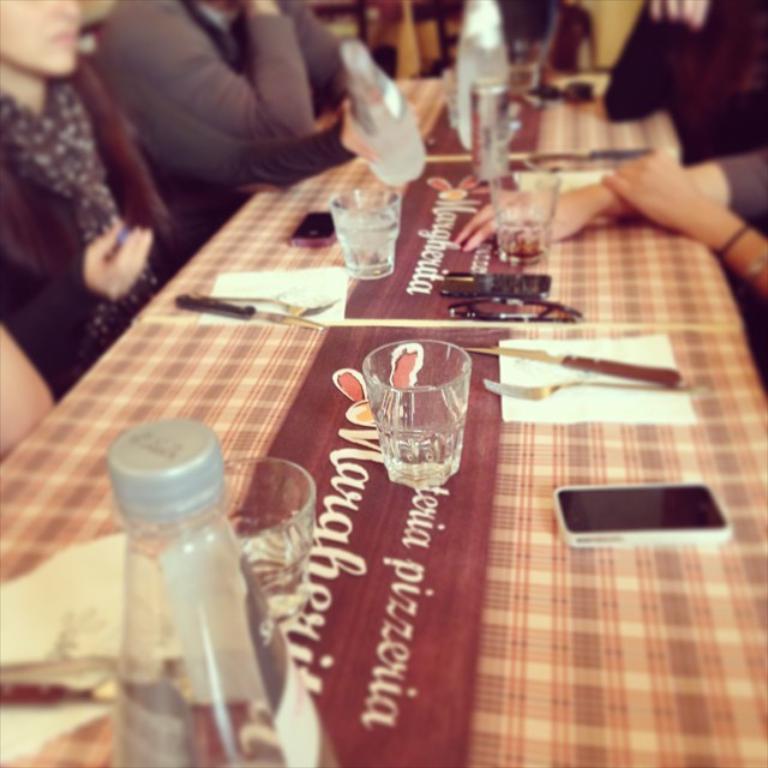Please provide a concise description of this image. In this image there are few people around the table, on the table there are glasses, bottles, tissue papers, knives, a mobile phone and some other objects. 